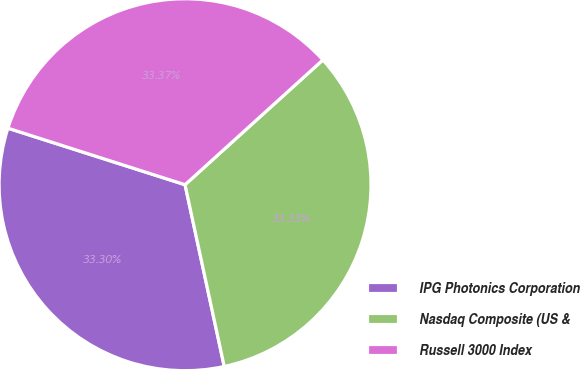Convert chart. <chart><loc_0><loc_0><loc_500><loc_500><pie_chart><fcel>IPG Photonics Corporation<fcel>Nasdaq Composite (US &<fcel>Russell 3000 Index<nl><fcel>33.3%<fcel>33.33%<fcel>33.37%<nl></chart> 